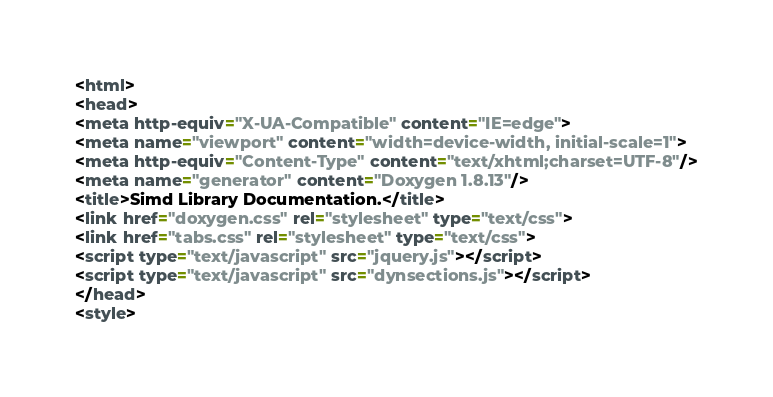Convert code to text. <code><loc_0><loc_0><loc_500><loc_500><_HTML_><html>
<head>
<meta http-equiv="X-UA-Compatible" content="IE=edge">
<meta name="viewport" content="width=device-width, initial-scale=1">
<meta http-equiv="Content-Type" content="text/xhtml;charset=UTF-8"/>
<meta name="generator" content="Doxygen 1.8.13"/>
<title>Simd Library Documentation.</title>
<link href="doxygen.css" rel="stylesheet" type="text/css">
<link href="tabs.css" rel="stylesheet" type="text/css">
<script type="text/javascript" src="jquery.js"></script>
<script type="text/javascript" src="dynsections.js"></script>
</head>
<style></code> 